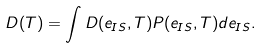Convert formula to latex. <formula><loc_0><loc_0><loc_500><loc_500>D ( T ) = \int D ( e _ { I S } , T ) P ( e _ { I S } , T ) d e _ { I S } .</formula> 